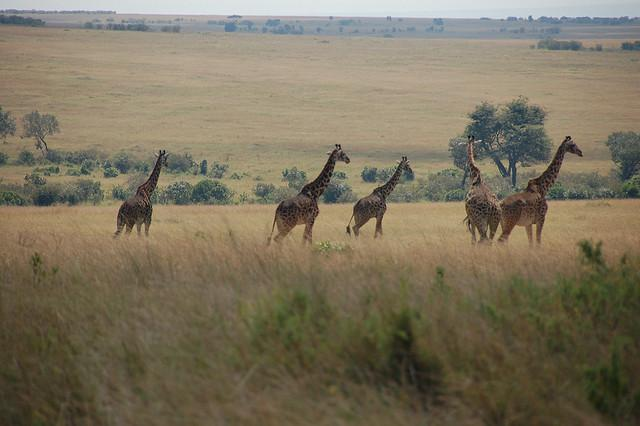Which giraffe is farthest from this small herd? Please explain your reasoning. far left. The giraffe is on the left. 